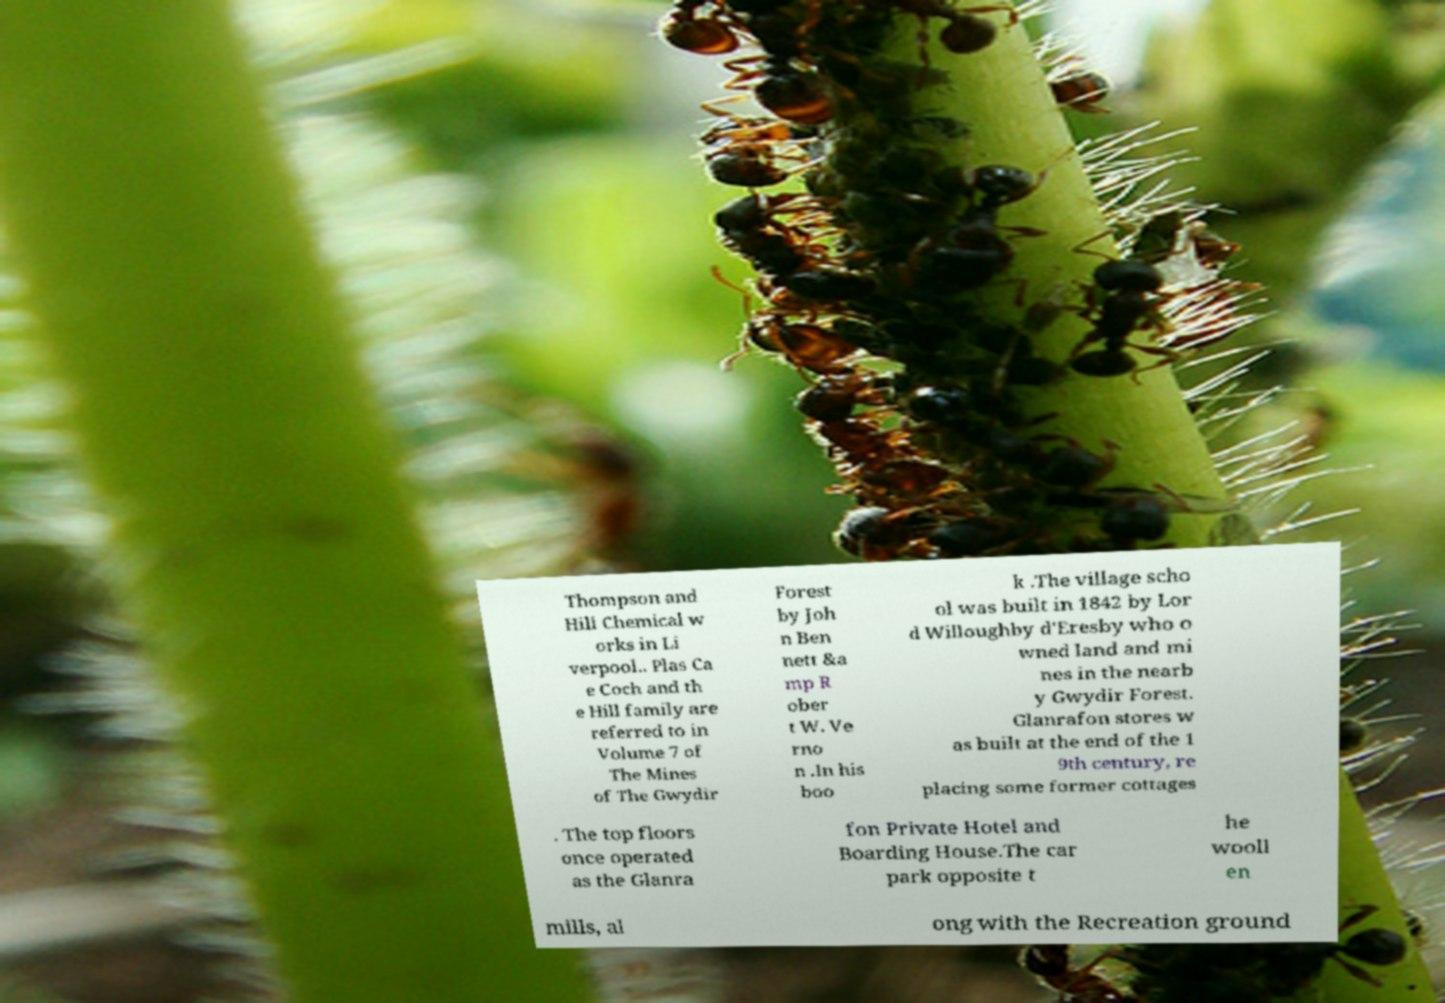For documentation purposes, I need the text within this image transcribed. Could you provide that? Thompson and Hill Chemical w orks in Li verpool.. Plas Ca e Coch and th e Hill family are referred to in Volume 7 of The Mines of The Gwydir Forest by Joh n Ben nett &a mp R ober t W. Ve rno n .In his boo k .The village scho ol was built in 1842 by Lor d Willoughby d'Eresby who o wned land and mi nes in the nearb y Gwydir Forest. Glanrafon stores w as built at the end of the 1 9th century, re placing some former cottages . The top floors once operated as the Glanra fon Private Hotel and Boarding House.The car park opposite t he wooll en mills, al ong with the Recreation ground 